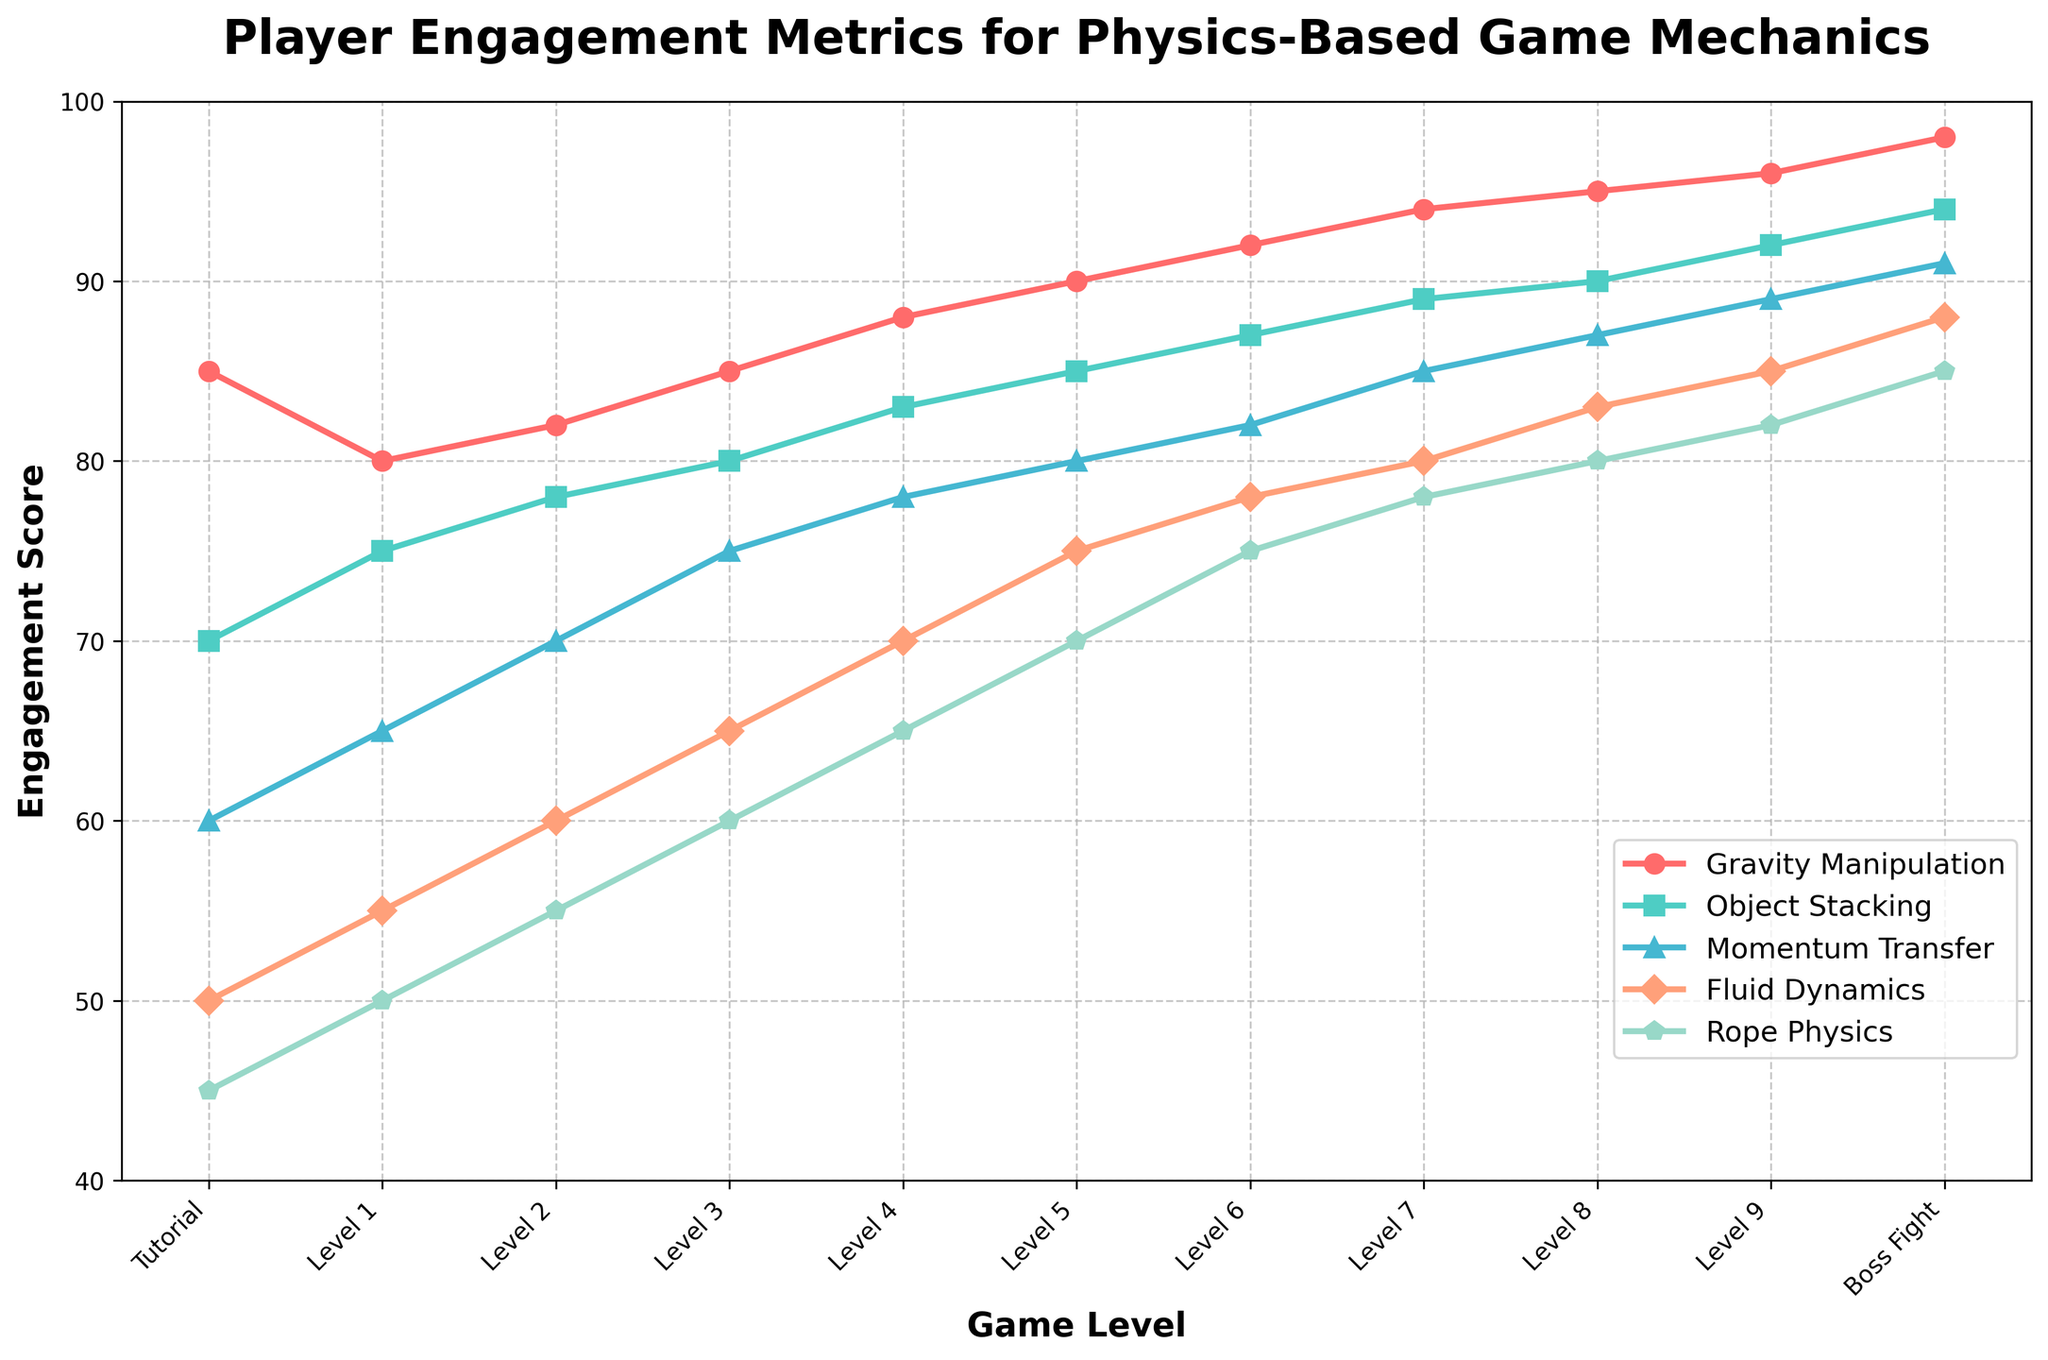What is the engagement score for Gravity Manipulation in the Boss Fight level? The engagement score for Gravity Manipulation in the Boss Fight level can be directly found by looking at the plot. Locate the Boss Fight level on the x-axis and find the corresponding y-axis value for the Gravity Manipulation line.
Answer: 98 Which game mechanic shows the largest increase in player engagement from Level 1 to Level 4? To find the mechanic with the largest increase, calculate the difference between Level 1 and Level 4 for each mechanic and compare them. For Gravity Manipulation: 88 - 80 = 8, for Object Stacking: 83 - 75 = 8, for Momentum Transfer: 78 - 65 = 13, for Fluid Dynamics: 70 - 55 = 15, for Rope Physics: 65 - 50 = 15. Therefore, Fluid Dynamics and Rope Physics show the largest increase.
Answer: Fluid Dynamics and Rope Physics Which level has the lowest engagement score for Fluid Dynamics? To find the level with the lowest engagement score for Fluid Dynamics, look at the values of Fluid Dynamics across all levels and identify the lowest value.
Answer: Tutorial How does player engagement in Rope Physics change from Level 5 to Level 9? To understand the change, look at the engagement scores for Rope Physics at Level 5 and Level 9 and calculate the difference. At Level 5, the score is 70, and at Level 9, it is 82. The change is 82 - 70 = 12.
Answer: It increases by 12 Among the mechanics, which one has the most steady increase in engagement scores over the levels? A steady increase means a consistent rise in engagement scores with minimal fluctuations. By observing the plot, we see that Gravity Manipulation shows a steady increase from the Tutorial to Boss Fight without any drops.
Answer: Gravity Manipulation Comparing Object Stacking and Momentum Transfer, which mechanic has a higher engagement score at Level 6 and by how much? Find the engagement scores for Object Stacking and Momentum Transfer at Level 6. For Object Stacking: 87, for Momentum Transfer: 82. Calculate the difference. 87 - 82 = 5.
Answer: Object Stacking by 5 What is the average engagement score for Fluid Dynamics from Level 1 to Level 5? Calculate the average engagement score by summing the values from Level 1 to Level 5 and dividing by the number of levels. (55 + 60 + 65 + 70 + 75) / 5 = 325 / 5 = 65
Answer: 65 Which mechanic has the highest engagement score in Level 3, and what is its value? Compare engagement scores for all mechanics in Level 3. Gravity Manipulation has 85, Object Stacking 80, Momentum Transfer 75, Fluid Dynamics 65, Rope Physics 60. The highest score is for Gravity Manipulation.
Answer: Gravity Manipulation with 85 Is there any level where all mechanics have engagement scores above 80? Check the engagement scores for all mechanics across each level. Levels 8, 9, and Boss Fight show scores above 80 for all mechanics.
Answer: Yes What is the total engagement score for Rope Physics across all levels? Sum the Rope Physics engagement scores across all levels: 45 + 50 + 55 + 60 + 65 + 70 + 75 + 78 + 80 + 82 + 85 = 745
Answer: 745 